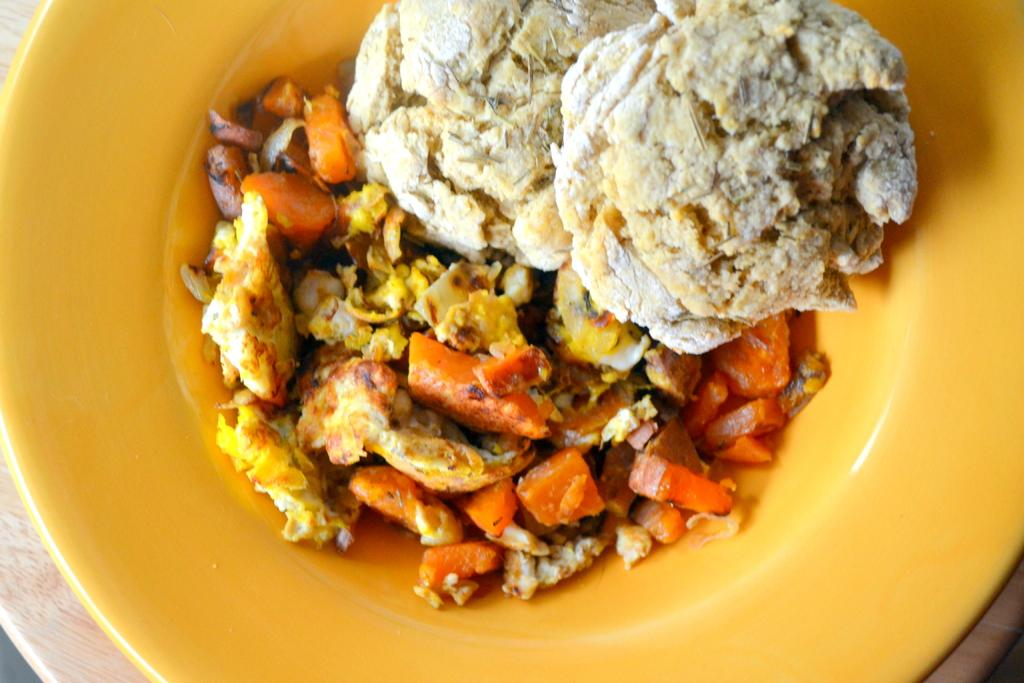What color is the plate that is visible in the image? The plate is yellow in color. What is on the plate in the image? The plate contains different types of food. Can you describe the colors of the food on the plate? The colors of the food on the plate include white, orange, and yellow. What type of magic is being performed with the food on the plate in the image? There is no magic being performed in the image; it simply shows a plate with different types of food. 